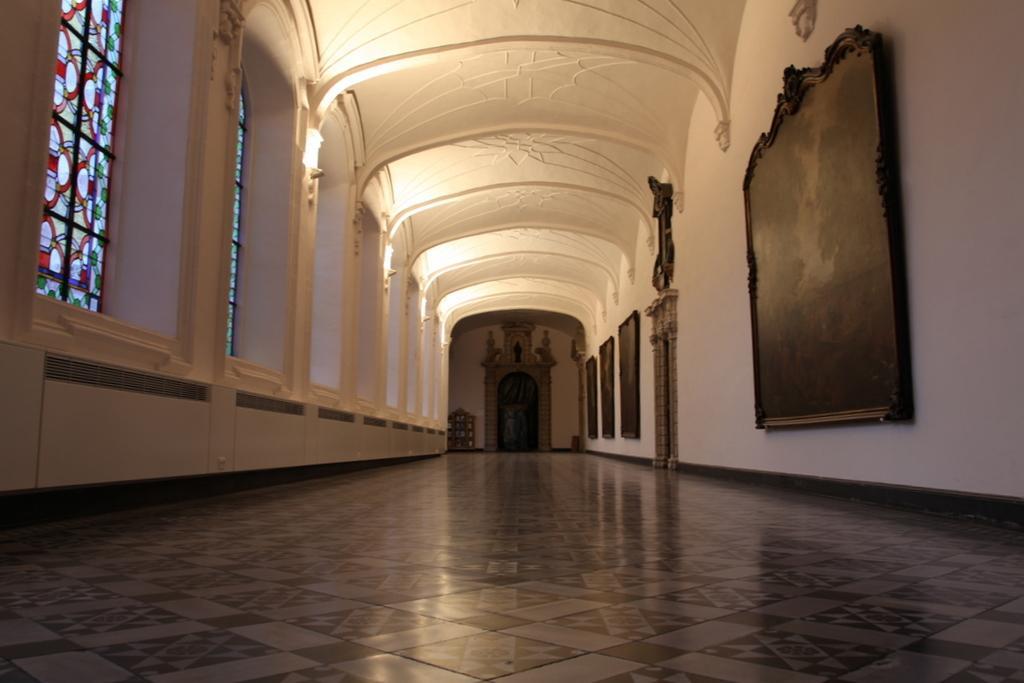Can you describe this image briefly? In the picture I can see the arch design construction. I can see the lamps on the wall. I can see the design glass windows on the left side. These are looking like wooden photo frames on the wall on the right side. I can see the marble flooring at the bottom of the picture. 